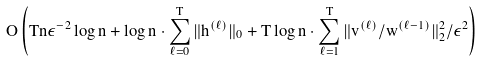Convert formula to latex. <formula><loc_0><loc_0><loc_500><loc_500>O \left ( T n \epsilon ^ { - 2 } \log n + \log n \cdot \sum _ { \ell = 0 } ^ { T } \| h ^ { ( \ell ) } \| _ { 0 } + T \log n \cdot \sum _ { \ell = 1 } ^ { T } \| v ^ { ( \ell ) } / w ^ { ( \ell - 1 ) } \| _ { 2 } ^ { 2 } / \epsilon ^ { 2 } \right )</formula> 